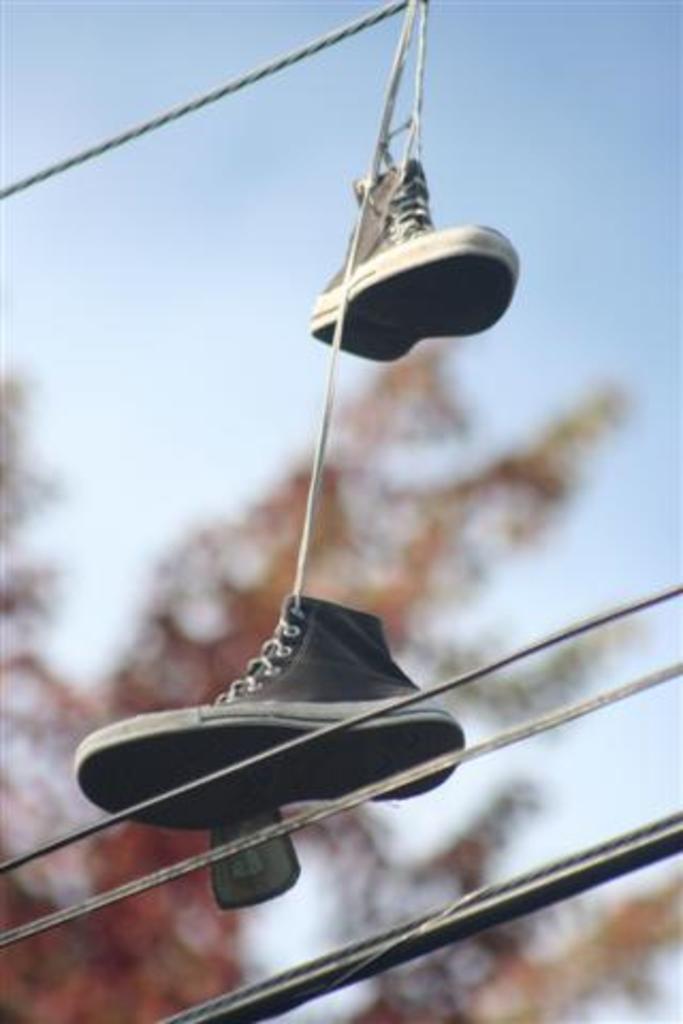Please provide a concise description of this image. In this image there are two shoes hanging may be on ropes, at the bottom may be there are some shoes, at the top there is the sky, may be a tree visible. 